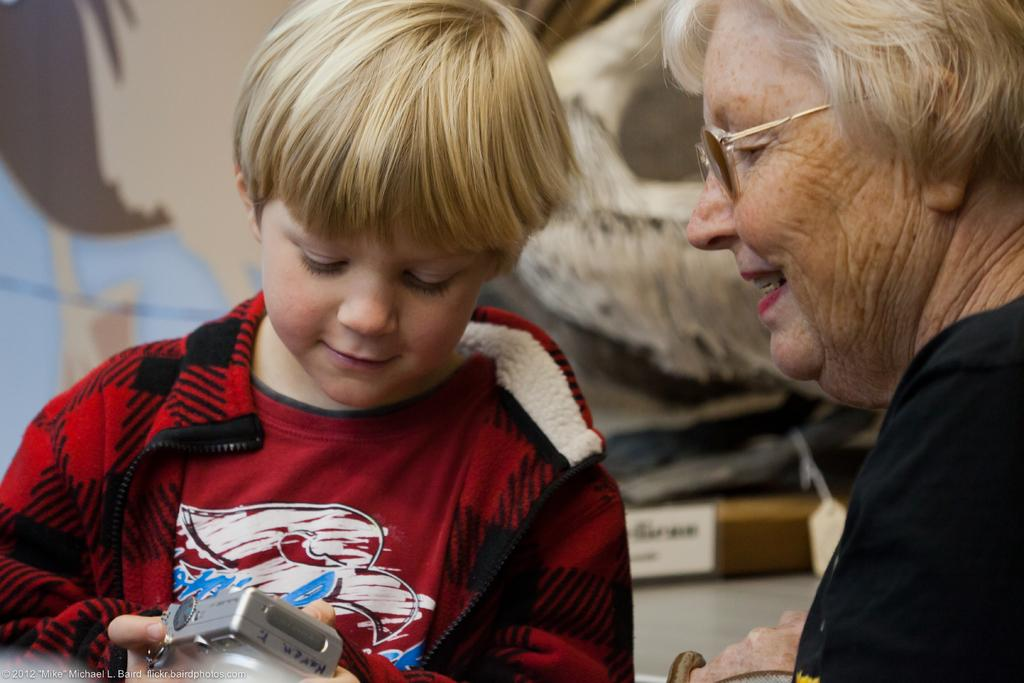How many people are present in the image? There are two people in the image. What is the kid holding in the image? The kid is holding a camera in the image. Can you describe the background of the image? The background of the image is blurred. Is there any text or logo visible in the image? Yes, there is a watermark in the bottom left side of the image. What type of whip is being used to attack the people in the image? There is no whip or attack present in the image; it features two people and a kid holding a camera. 